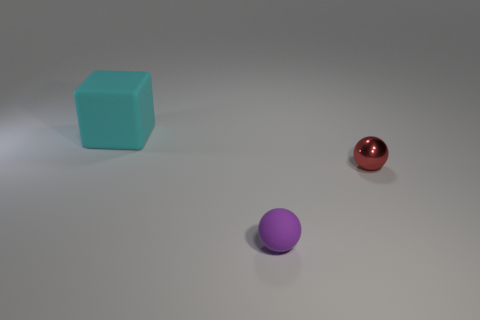Add 1 metal spheres. How many objects exist? 4 Subtract all balls. How many objects are left? 1 Add 1 matte blocks. How many matte blocks are left? 2 Add 1 small blue matte spheres. How many small blue matte spheres exist? 1 Subtract 0 cyan spheres. How many objects are left? 3 Subtract all small green rubber cylinders. Subtract all tiny red balls. How many objects are left? 2 